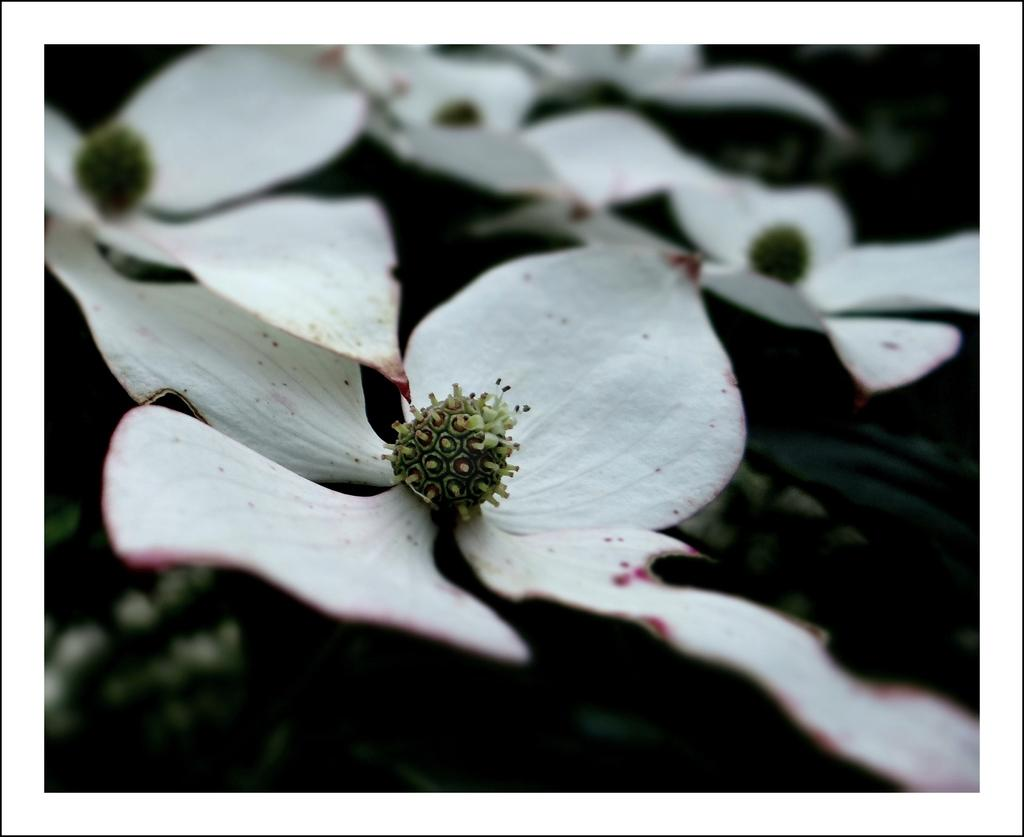What type of flowers are present in the image? There are white color flowers in the image. What trail can be seen in the image? There is no trail present in the image; it only features white color flowers. What month is it in the image? The month cannot be determined from the image, as it only shows white color flowers. 